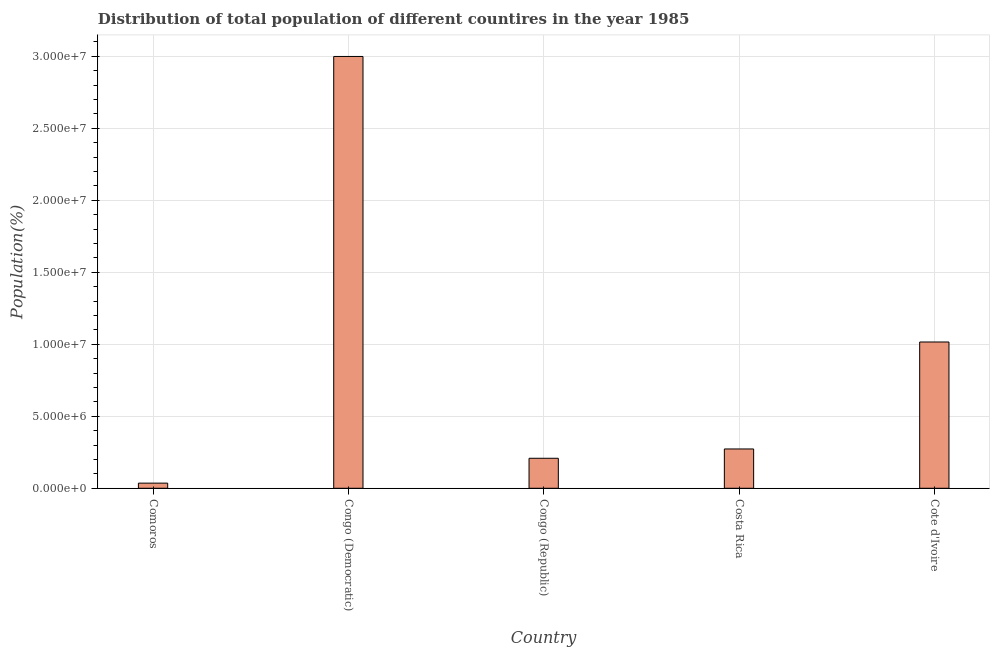Does the graph contain any zero values?
Provide a succinct answer. No. Does the graph contain grids?
Your response must be concise. Yes. What is the title of the graph?
Offer a terse response. Distribution of total population of different countires in the year 1985. What is the label or title of the Y-axis?
Keep it short and to the point. Population(%). What is the population in Congo (Democratic)?
Your answer should be very brief. 3.00e+07. Across all countries, what is the maximum population?
Your answer should be compact. 3.00e+07. Across all countries, what is the minimum population?
Keep it short and to the point. 3.58e+05. In which country was the population maximum?
Provide a short and direct response. Congo (Democratic). In which country was the population minimum?
Offer a very short reply. Comoros. What is the sum of the population?
Ensure brevity in your answer.  4.53e+07. What is the difference between the population in Congo (Democratic) and Congo (Republic)?
Your response must be concise. 2.79e+07. What is the average population per country?
Your answer should be compact. 9.06e+06. What is the median population?
Keep it short and to the point. 2.73e+06. In how many countries, is the population greater than 23000000 %?
Make the answer very short. 1. What is the ratio of the population in Congo (Democratic) to that in Cote d'Ivoire?
Give a very brief answer. 2.95. Is the population in Congo (Republic) less than that in Cote d'Ivoire?
Your answer should be very brief. Yes. What is the difference between the highest and the second highest population?
Ensure brevity in your answer.  1.98e+07. What is the difference between the highest and the lowest population?
Keep it short and to the point. 2.96e+07. How many bars are there?
Provide a succinct answer. 5. Are the values on the major ticks of Y-axis written in scientific E-notation?
Offer a very short reply. Yes. What is the Population(%) in Comoros?
Give a very brief answer. 3.58e+05. What is the Population(%) of Congo (Democratic)?
Make the answer very short. 3.00e+07. What is the Population(%) in Congo (Republic)?
Your answer should be compact. 2.08e+06. What is the Population(%) in Costa Rica?
Make the answer very short. 2.73e+06. What is the Population(%) in Cote d'Ivoire?
Provide a short and direct response. 1.02e+07. What is the difference between the Population(%) in Comoros and Congo (Democratic)?
Keep it short and to the point. -2.96e+07. What is the difference between the Population(%) in Comoros and Congo (Republic)?
Offer a terse response. -1.73e+06. What is the difference between the Population(%) in Comoros and Costa Rica?
Your response must be concise. -2.37e+06. What is the difference between the Population(%) in Comoros and Cote d'Ivoire?
Make the answer very short. -9.80e+06. What is the difference between the Population(%) in Congo (Democratic) and Congo (Republic)?
Ensure brevity in your answer.  2.79e+07. What is the difference between the Population(%) in Congo (Democratic) and Costa Rica?
Give a very brief answer. 2.73e+07. What is the difference between the Population(%) in Congo (Democratic) and Cote d'Ivoire?
Offer a very short reply. 1.98e+07. What is the difference between the Population(%) in Congo (Republic) and Costa Rica?
Provide a short and direct response. -6.47e+05. What is the difference between the Population(%) in Congo (Republic) and Cote d'Ivoire?
Offer a terse response. -8.07e+06. What is the difference between the Population(%) in Costa Rica and Cote d'Ivoire?
Your answer should be very brief. -7.43e+06. What is the ratio of the Population(%) in Comoros to that in Congo (Democratic)?
Ensure brevity in your answer.  0.01. What is the ratio of the Population(%) in Comoros to that in Congo (Republic)?
Offer a very short reply. 0.17. What is the ratio of the Population(%) in Comoros to that in Costa Rica?
Ensure brevity in your answer.  0.13. What is the ratio of the Population(%) in Comoros to that in Cote d'Ivoire?
Offer a terse response. 0.04. What is the ratio of the Population(%) in Congo (Democratic) to that in Congo (Republic)?
Ensure brevity in your answer.  14.39. What is the ratio of the Population(%) in Congo (Democratic) to that in Costa Rica?
Provide a short and direct response. 10.98. What is the ratio of the Population(%) in Congo (Democratic) to that in Cote d'Ivoire?
Your answer should be compact. 2.95. What is the ratio of the Population(%) in Congo (Republic) to that in Costa Rica?
Your answer should be compact. 0.76. What is the ratio of the Population(%) in Congo (Republic) to that in Cote d'Ivoire?
Your response must be concise. 0.2. What is the ratio of the Population(%) in Costa Rica to that in Cote d'Ivoire?
Provide a short and direct response. 0.27. 